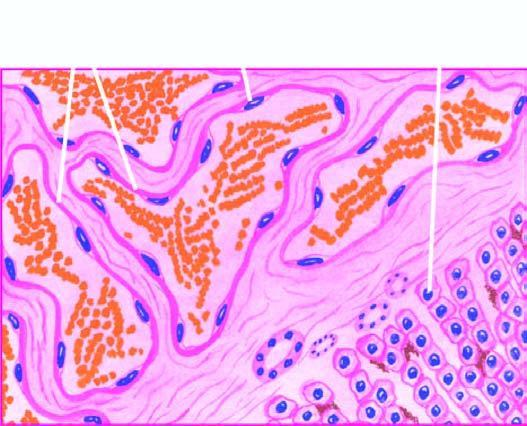s central coagulative necrosis seen between the cavernous spaces?
Answer the question using a single word or phrase. No 